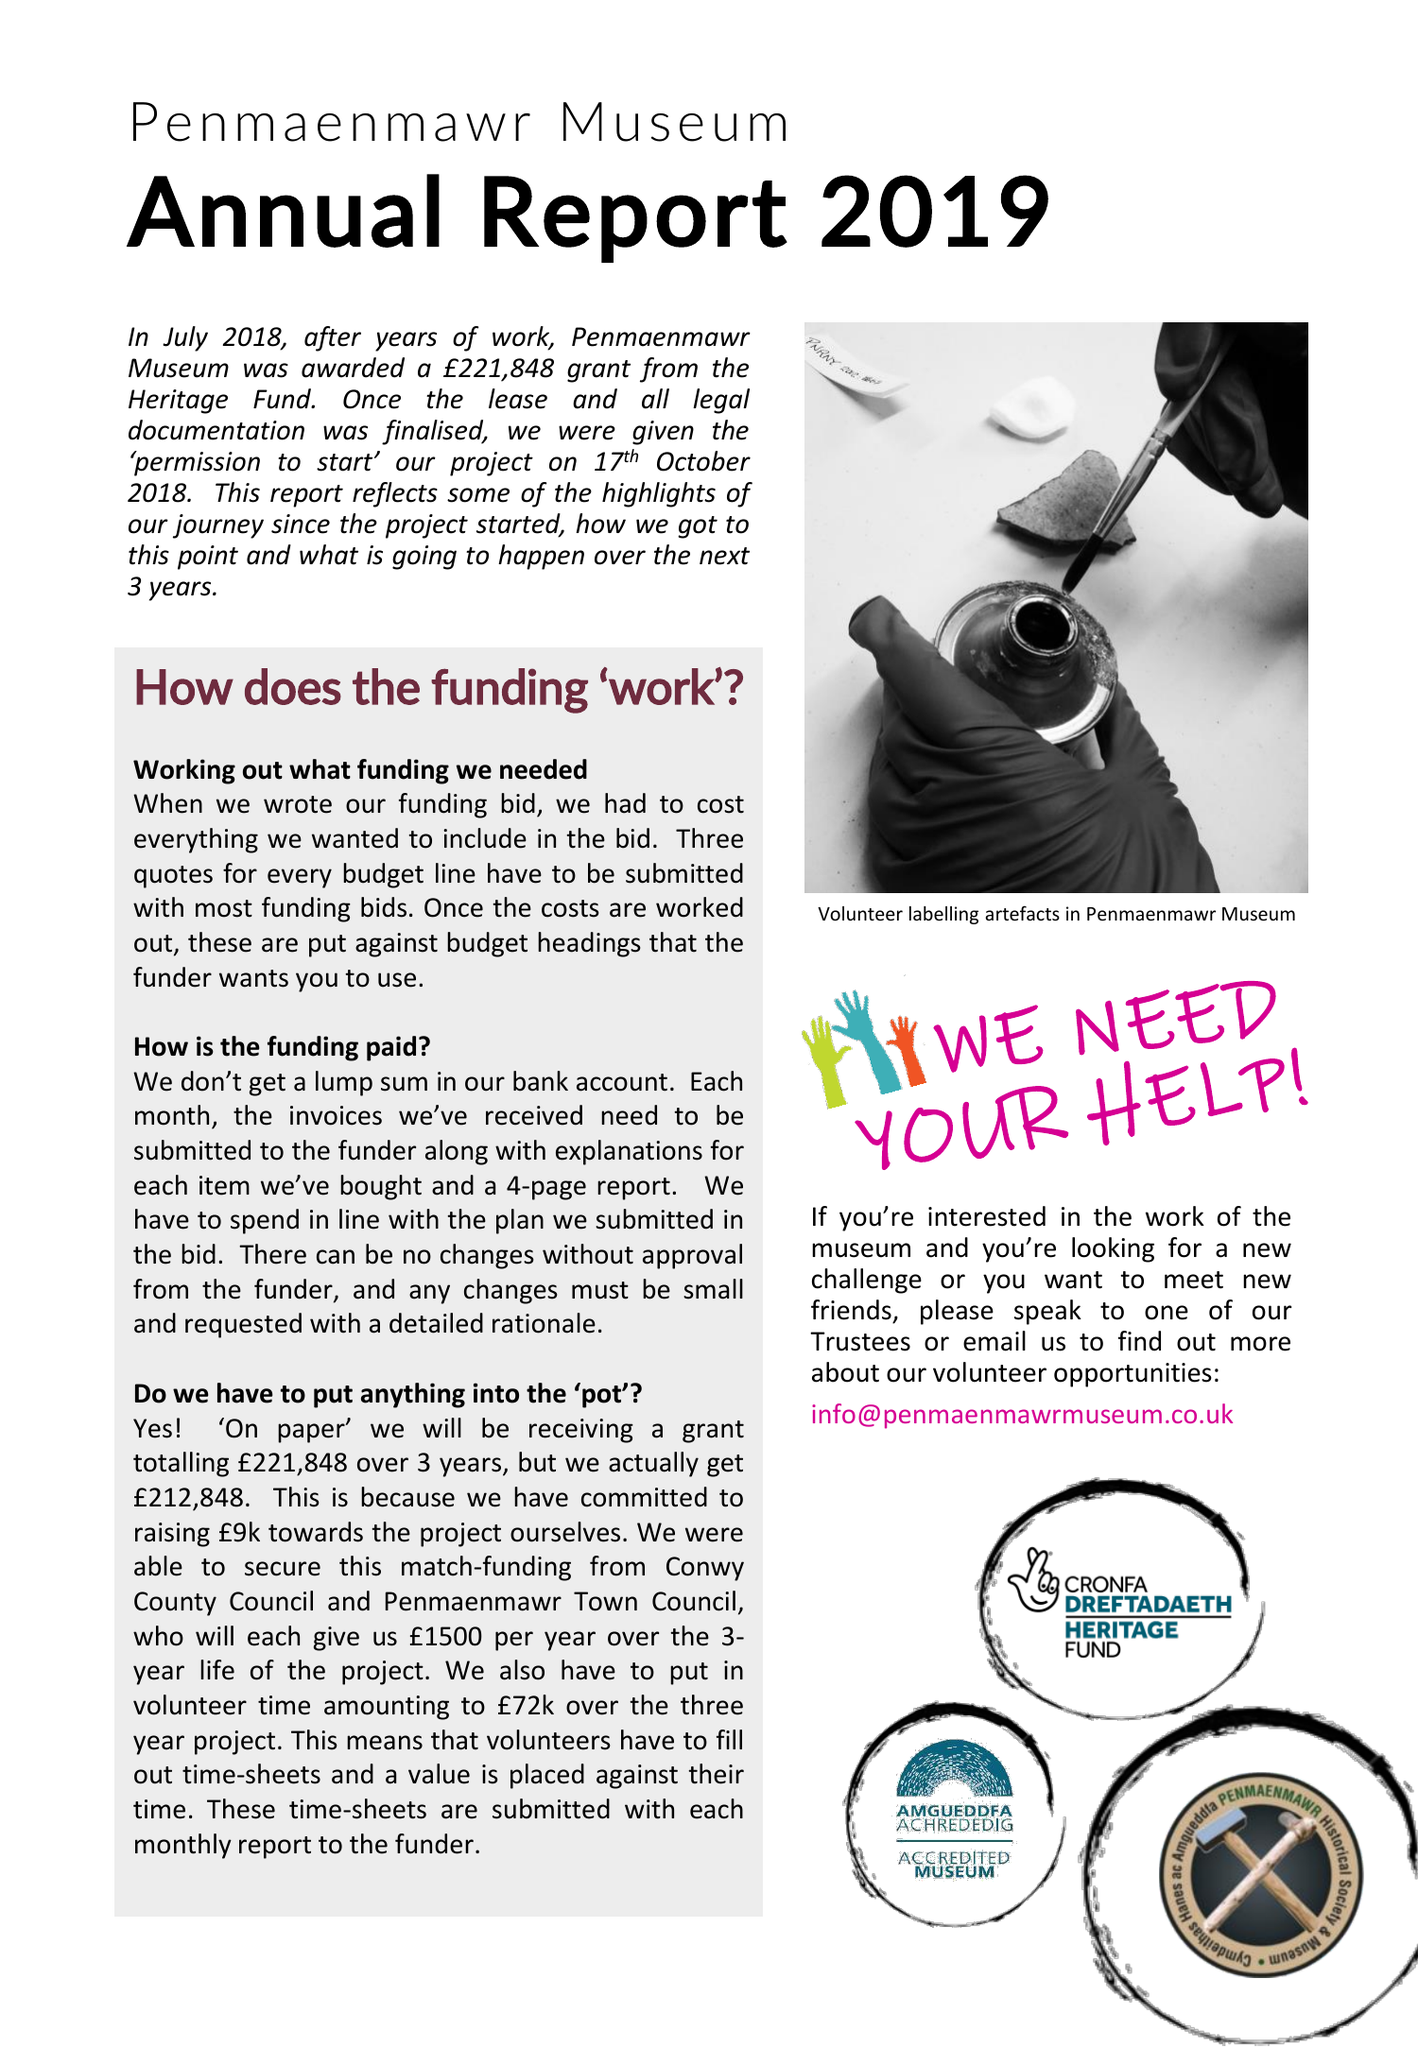What is the value for the address__post_town?
Answer the question using a single word or phrase. PENMAENMAWR 